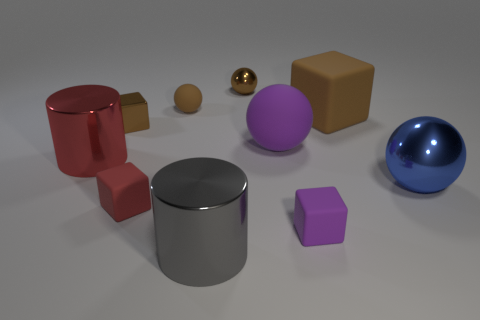Are there any tiny blocks that have the same color as the large matte cube?
Provide a short and direct response. Yes. Are there any other things that have the same color as the big matte block?
Ensure brevity in your answer.  Yes. There is a brown object to the right of the purple object to the right of the purple matte ball; is there a large purple sphere to the right of it?
Provide a short and direct response. No. The brown block that is the same material as the big purple object is what size?
Your answer should be very brief. Large. There is a blue object; are there any small brown metal objects behind it?
Your answer should be compact. Yes. There is a purple thing that is in front of the large red object; is there a small rubber cube that is to the left of it?
Provide a short and direct response. Yes. There is a object that is on the right side of the big brown rubber object; does it have the same size as the brown block on the left side of the big rubber sphere?
Offer a very short reply. No. What number of large things are either purple cubes or blue balls?
Your response must be concise. 1. What material is the large object that is on the left side of the cylinder that is in front of the big red shiny object made of?
Your response must be concise. Metal. There is a small matte thing that is the same color as the tiny metallic sphere; what shape is it?
Ensure brevity in your answer.  Sphere. 